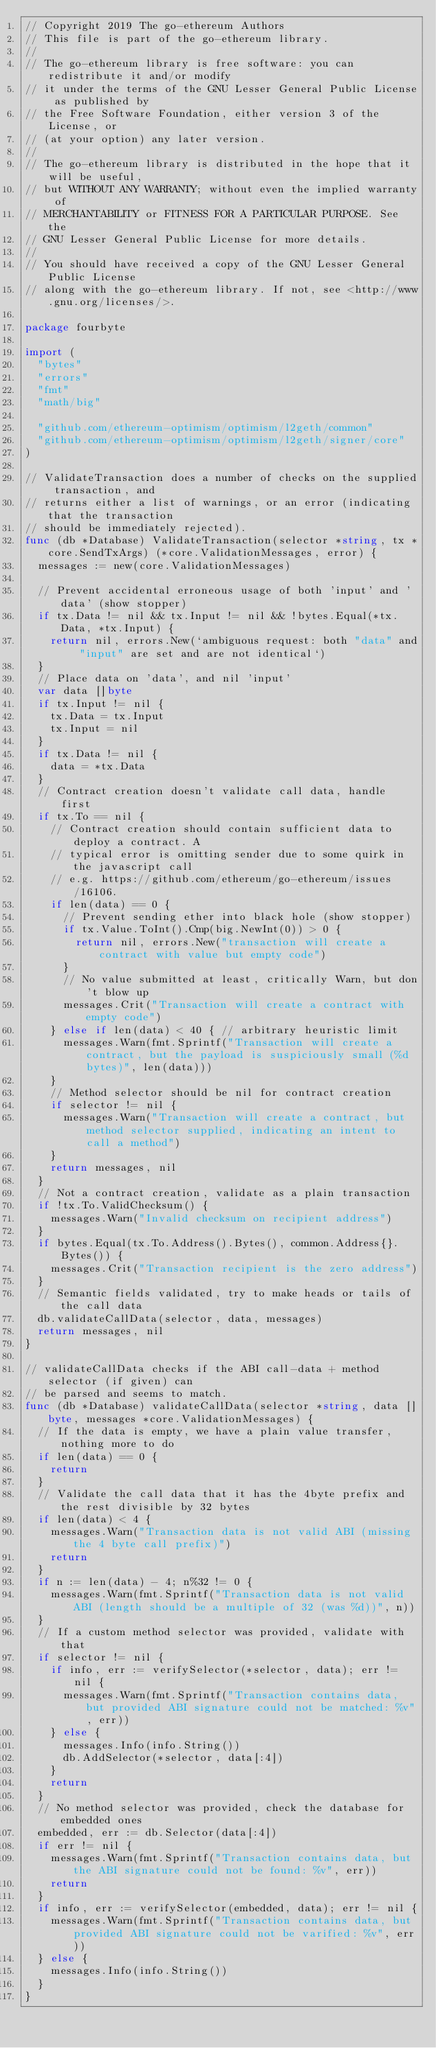Convert code to text. <code><loc_0><loc_0><loc_500><loc_500><_Go_>// Copyright 2019 The go-ethereum Authors
// This file is part of the go-ethereum library.
//
// The go-ethereum library is free software: you can redistribute it and/or modify
// it under the terms of the GNU Lesser General Public License as published by
// the Free Software Foundation, either version 3 of the License, or
// (at your option) any later version.
//
// The go-ethereum library is distributed in the hope that it will be useful,
// but WITHOUT ANY WARRANTY; without even the implied warranty of
// MERCHANTABILITY or FITNESS FOR A PARTICULAR PURPOSE. See the
// GNU Lesser General Public License for more details.
//
// You should have received a copy of the GNU Lesser General Public License
// along with the go-ethereum library. If not, see <http://www.gnu.org/licenses/>.

package fourbyte

import (
	"bytes"
	"errors"
	"fmt"
	"math/big"

	"github.com/ethereum-optimism/optimism/l2geth/common"
	"github.com/ethereum-optimism/optimism/l2geth/signer/core"
)

// ValidateTransaction does a number of checks on the supplied transaction, and
// returns either a list of warnings, or an error (indicating that the transaction
// should be immediately rejected).
func (db *Database) ValidateTransaction(selector *string, tx *core.SendTxArgs) (*core.ValidationMessages, error) {
	messages := new(core.ValidationMessages)

	// Prevent accidental erroneous usage of both 'input' and 'data' (show stopper)
	if tx.Data != nil && tx.Input != nil && !bytes.Equal(*tx.Data, *tx.Input) {
		return nil, errors.New(`ambiguous request: both "data" and "input" are set and are not identical`)
	}
	// Place data on 'data', and nil 'input'
	var data []byte
	if tx.Input != nil {
		tx.Data = tx.Input
		tx.Input = nil
	}
	if tx.Data != nil {
		data = *tx.Data
	}
	// Contract creation doesn't validate call data, handle first
	if tx.To == nil {
		// Contract creation should contain sufficient data to deploy a contract. A
		// typical error is omitting sender due to some quirk in the javascript call
		// e.g. https://github.com/ethereum/go-ethereum/issues/16106.
		if len(data) == 0 {
			// Prevent sending ether into black hole (show stopper)
			if tx.Value.ToInt().Cmp(big.NewInt(0)) > 0 {
				return nil, errors.New("transaction will create a contract with value but empty code")
			}
			// No value submitted at least, critically Warn, but don't blow up
			messages.Crit("Transaction will create a contract with empty code")
		} else if len(data) < 40 { // arbitrary heuristic limit
			messages.Warn(fmt.Sprintf("Transaction will create a contract, but the payload is suspiciously small (%d bytes)", len(data)))
		}
		// Method selector should be nil for contract creation
		if selector != nil {
			messages.Warn("Transaction will create a contract, but method selector supplied, indicating an intent to call a method")
		}
		return messages, nil
	}
	// Not a contract creation, validate as a plain transaction
	if !tx.To.ValidChecksum() {
		messages.Warn("Invalid checksum on recipient address")
	}
	if bytes.Equal(tx.To.Address().Bytes(), common.Address{}.Bytes()) {
		messages.Crit("Transaction recipient is the zero address")
	}
	// Semantic fields validated, try to make heads or tails of the call data
	db.validateCallData(selector, data, messages)
	return messages, nil
}

// validateCallData checks if the ABI call-data + method selector (if given) can
// be parsed and seems to match.
func (db *Database) validateCallData(selector *string, data []byte, messages *core.ValidationMessages) {
	// If the data is empty, we have a plain value transfer, nothing more to do
	if len(data) == 0 {
		return
	}
	// Validate the call data that it has the 4byte prefix and the rest divisible by 32 bytes
	if len(data) < 4 {
		messages.Warn("Transaction data is not valid ABI (missing the 4 byte call prefix)")
		return
	}
	if n := len(data) - 4; n%32 != 0 {
		messages.Warn(fmt.Sprintf("Transaction data is not valid ABI (length should be a multiple of 32 (was %d))", n))
	}
	// If a custom method selector was provided, validate with that
	if selector != nil {
		if info, err := verifySelector(*selector, data); err != nil {
			messages.Warn(fmt.Sprintf("Transaction contains data, but provided ABI signature could not be matched: %v", err))
		} else {
			messages.Info(info.String())
			db.AddSelector(*selector, data[:4])
		}
		return
	}
	// No method selector was provided, check the database for embedded ones
	embedded, err := db.Selector(data[:4])
	if err != nil {
		messages.Warn(fmt.Sprintf("Transaction contains data, but the ABI signature could not be found: %v", err))
		return
	}
	if info, err := verifySelector(embedded, data); err != nil {
		messages.Warn(fmt.Sprintf("Transaction contains data, but provided ABI signature could not be varified: %v", err))
	} else {
		messages.Info(info.String())
	}
}
</code> 